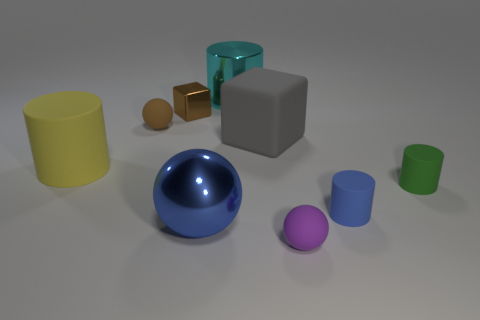Subtract all blue matte cylinders. How many cylinders are left? 3 Subtract all cyan cylinders. How many cylinders are left? 3 Subtract 1 spheres. How many spheres are left? 2 Subtract all gray cylinders. Subtract all purple cubes. How many cylinders are left? 4 Subtract all blocks. How many objects are left? 7 Subtract all tiny blue things. Subtract all small purple matte objects. How many objects are left? 7 Add 4 purple balls. How many purple balls are left? 5 Add 4 gray objects. How many gray objects exist? 5 Subtract 0 gray cylinders. How many objects are left? 9 